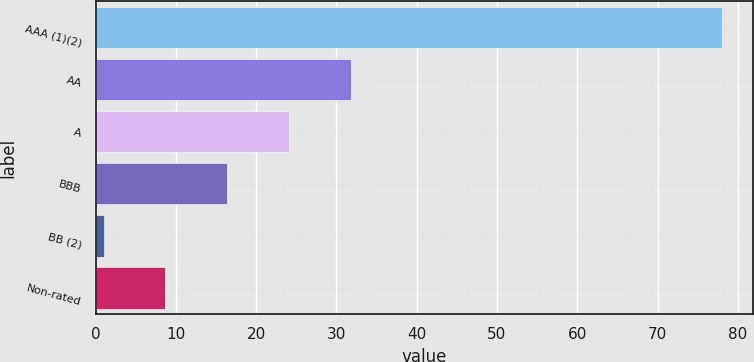Convert chart to OTSL. <chart><loc_0><loc_0><loc_500><loc_500><bar_chart><fcel>AAA (1)(2)<fcel>AA<fcel>A<fcel>BBB<fcel>BB (2)<fcel>Non-rated<nl><fcel>78<fcel>31.8<fcel>24.1<fcel>16.4<fcel>1<fcel>8.7<nl></chart> 